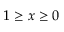Convert formula to latex. <formula><loc_0><loc_0><loc_500><loc_500>1 \geq x \geq 0</formula> 